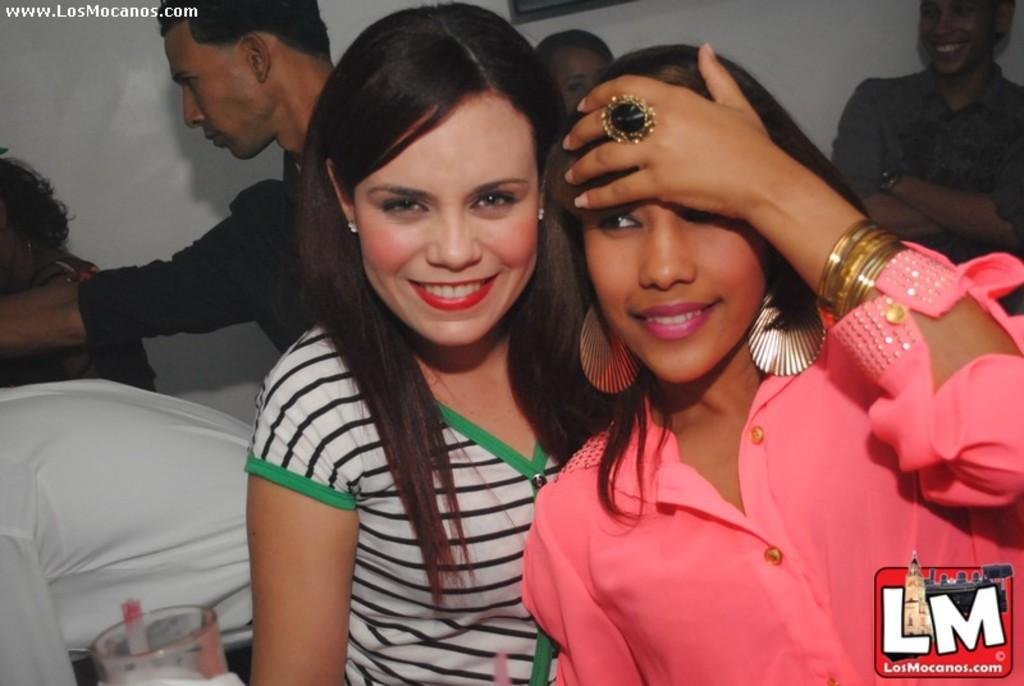How many people are in the image? There are persons in the image, but the exact number is not specified. What is the facial expression of the persons in the image? The persons in the image are smiling. What object can be seen in the image besides the persons? There is a glass in the image. What can be seen on the glass in the image? There is a logo on the glass in the image. What is visible in the background of the image? There is a wall in the background of the image. What type of riddle is being solved by the persons in the image? There is no riddle present in the image; the persons are simply smiling. How much wealth is visible in the image? There is no indication of wealth in the image; it only features persons, a glass, a logo, and a wall. 